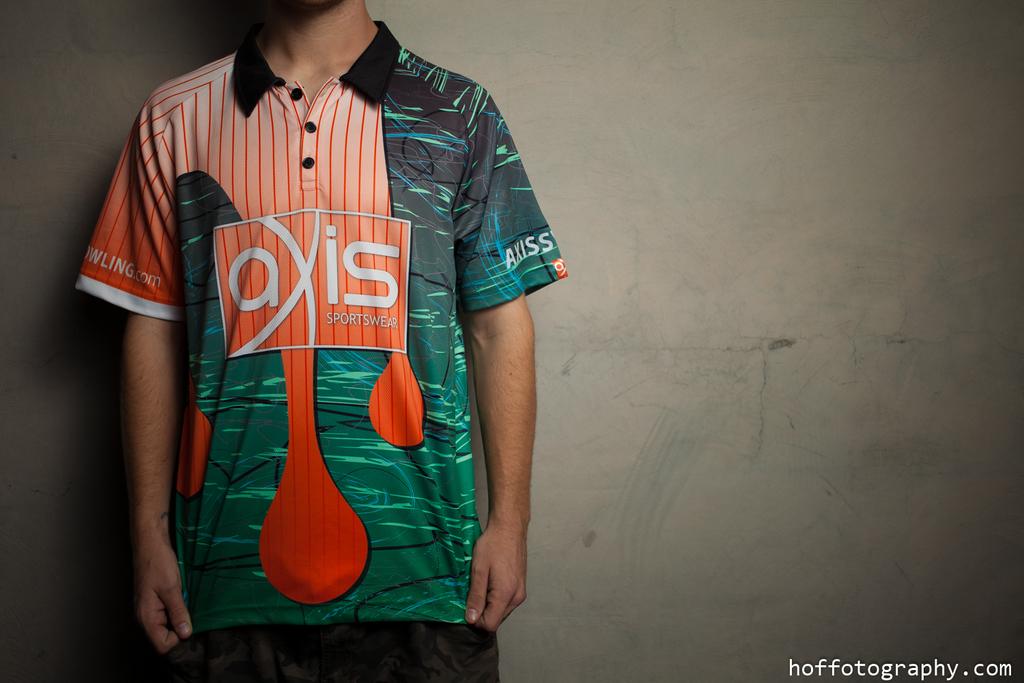Is he wearing something related to sports?
Provide a short and direct response. Yes. What brand is this shirt?
Ensure brevity in your answer.  Axis. 